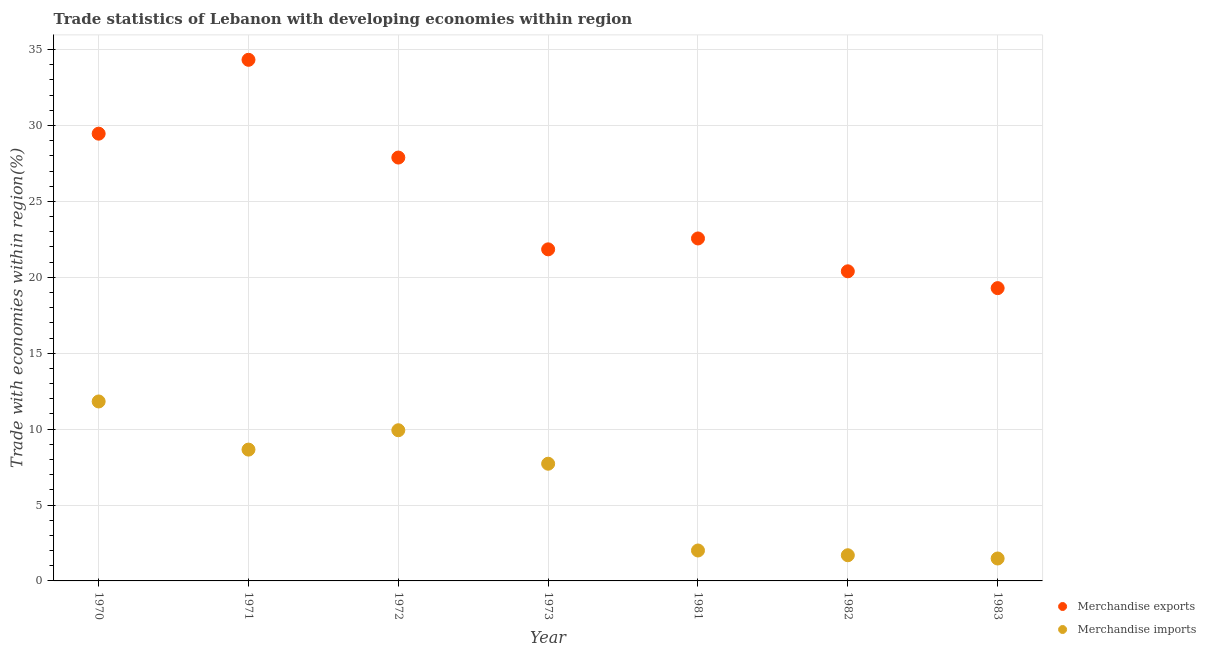How many different coloured dotlines are there?
Your answer should be very brief. 2. What is the merchandise exports in 1970?
Your answer should be compact. 29.46. Across all years, what is the maximum merchandise imports?
Offer a terse response. 11.82. Across all years, what is the minimum merchandise exports?
Ensure brevity in your answer.  19.29. In which year was the merchandise imports maximum?
Keep it short and to the point. 1970. In which year was the merchandise imports minimum?
Offer a terse response. 1983. What is the total merchandise imports in the graph?
Provide a succinct answer. 43.29. What is the difference between the merchandise exports in 1971 and that in 1981?
Your response must be concise. 11.77. What is the difference between the merchandise imports in 1983 and the merchandise exports in 1971?
Ensure brevity in your answer.  -32.85. What is the average merchandise exports per year?
Provide a succinct answer. 25.11. In the year 1973, what is the difference between the merchandise exports and merchandise imports?
Provide a short and direct response. 14.12. In how many years, is the merchandise imports greater than 33 %?
Offer a very short reply. 0. What is the ratio of the merchandise exports in 1972 to that in 1973?
Offer a terse response. 1.28. Is the difference between the merchandise exports in 1971 and 1982 greater than the difference between the merchandise imports in 1971 and 1982?
Ensure brevity in your answer.  Yes. What is the difference between the highest and the second highest merchandise imports?
Provide a succinct answer. 1.9. What is the difference between the highest and the lowest merchandise imports?
Give a very brief answer. 10.34. In how many years, is the merchandise exports greater than the average merchandise exports taken over all years?
Give a very brief answer. 3. Does the graph contain grids?
Your response must be concise. Yes. How are the legend labels stacked?
Offer a very short reply. Vertical. What is the title of the graph?
Your answer should be compact. Trade statistics of Lebanon with developing economies within region. Does "Research and Development" appear as one of the legend labels in the graph?
Your answer should be compact. No. What is the label or title of the Y-axis?
Offer a very short reply. Trade with economies within region(%). What is the Trade with economies within region(%) of Merchandise exports in 1970?
Your response must be concise. 29.46. What is the Trade with economies within region(%) of Merchandise imports in 1970?
Provide a short and direct response. 11.82. What is the Trade with economies within region(%) in Merchandise exports in 1971?
Offer a terse response. 34.33. What is the Trade with economies within region(%) in Merchandise imports in 1971?
Your response must be concise. 8.65. What is the Trade with economies within region(%) of Merchandise exports in 1972?
Give a very brief answer. 27.89. What is the Trade with economies within region(%) in Merchandise imports in 1972?
Provide a short and direct response. 9.93. What is the Trade with economies within region(%) of Merchandise exports in 1973?
Make the answer very short. 21.84. What is the Trade with economies within region(%) of Merchandise imports in 1973?
Ensure brevity in your answer.  7.72. What is the Trade with economies within region(%) of Merchandise exports in 1981?
Your answer should be compact. 22.56. What is the Trade with economies within region(%) in Merchandise imports in 1981?
Offer a terse response. 2. What is the Trade with economies within region(%) of Merchandise exports in 1982?
Your answer should be compact. 20.4. What is the Trade with economies within region(%) of Merchandise imports in 1982?
Offer a terse response. 1.69. What is the Trade with economies within region(%) in Merchandise exports in 1983?
Ensure brevity in your answer.  19.29. What is the Trade with economies within region(%) in Merchandise imports in 1983?
Ensure brevity in your answer.  1.48. Across all years, what is the maximum Trade with economies within region(%) in Merchandise exports?
Provide a succinct answer. 34.33. Across all years, what is the maximum Trade with economies within region(%) of Merchandise imports?
Your answer should be compact. 11.82. Across all years, what is the minimum Trade with economies within region(%) in Merchandise exports?
Offer a terse response. 19.29. Across all years, what is the minimum Trade with economies within region(%) of Merchandise imports?
Your answer should be compact. 1.48. What is the total Trade with economies within region(%) in Merchandise exports in the graph?
Provide a succinct answer. 175.76. What is the total Trade with economies within region(%) of Merchandise imports in the graph?
Your response must be concise. 43.29. What is the difference between the Trade with economies within region(%) of Merchandise exports in 1970 and that in 1971?
Provide a short and direct response. -4.87. What is the difference between the Trade with economies within region(%) of Merchandise imports in 1970 and that in 1971?
Your response must be concise. 3.17. What is the difference between the Trade with economies within region(%) of Merchandise exports in 1970 and that in 1972?
Keep it short and to the point. 1.57. What is the difference between the Trade with economies within region(%) of Merchandise imports in 1970 and that in 1972?
Give a very brief answer. 1.9. What is the difference between the Trade with economies within region(%) of Merchandise exports in 1970 and that in 1973?
Your answer should be compact. 7.62. What is the difference between the Trade with economies within region(%) in Merchandise imports in 1970 and that in 1973?
Your answer should be very brief. 4.1. What is the difference between the Trade with economies within region(%) in Merchandise exports in 1970 and that in 1981?
Ensure brevity in your answer.  6.9. What is the difference between the Trade with economies within region(%) of Merchandise imports in 1970 and that in 1981?
Ensure brevity in your answer.  9.82. What is the difference between the Trade with economies within region(%) of Merchandise exports in 1970 and that in 1982?
Keep it short and to the point. 9.07. What is the difference between the Trade with economies within region(%) of Merchandise imports in 1970 and that in 1982?
Provide a succinct answer. 10.13. What is the difference between the Trade with economies within region(%) in Merchandise exports in 1970 and that in 1983?
Provide a short and direct response. 10.18. What is the difference between the Trade with economies within region(%) of Merchandise imports in 1970 and that in 1983?
Offer a terse response. 10.34. What is the difference between the Trade with economies within region(%) of Merchandise exports in 1971 and that in 1972?
Give a very brief answer. 6.44. What is the difference between the Trade with economies within region(%) of Merchandise imports in 1971 and that in 1972?
Keep it short and to the point. -1.28. What is the difference between the Trade with economies within region(%) in Merchandise exports in 1971 and that in 1973?
Your answer should be compact. 12.49. What is the difference between the Trade with economies within region(%) in Merchandise exports in 1971 and that in 1981?
Your response must be concise. 11.77. What is the difference between the Trade with economies within region(%) in Merchandise imports in 1971 and that in 1981?
Your answer should be very brief. 6.65. What is the difference between the Trade with economies within region(%) of Merchandise exports in 1971 and that in 1982?
Provide a succinct answer. 13.93. What is the difference between the Trade with economies within region(%) of Merchandise imports in 1971 and that in 1982?
Your answer should be compact. 6.96. What is the difference between the Trade with economies within region(%) in Merchandise exports in 1971 and that in 1983?
Your response must be concise. 15.04. What is the difference between the Trade with economies within region(%) in Merchandise imports in 1971 and that in 1983?
Offer a terse response. 7.17. What is the difference between the Trade with economies within region(%) in Merchandise exports in 1972 and that in 1973?
Keep it short and to the point. 6.05. What is the difference between the Trade with economies within region(%) in Merchandise imports in 1972 and that in 1973?
Your answer should be very brief. 2.21. What is the difference between the Trade with economies within region(%) in Merchandise exports in 1972 and that in 1981?
Your answer should be very brief. 5.33. What is the difference between the Trade with economies within region(%) in Merchandise imports in 1972 and that in 1981?
Your answer should be compact. 7.92. What is the difference between the Trade with economies within region(%) of Merchandise exports in 1972 and that in 1982?
Provide a short and direct response. 7.49. What is the difference between the Trade with economies within region(%) in Merchandise imports in 1972 and that in 1982?
Ensure brevity in your answer.  8.23. What is the difference between the Trade with economies within region(%) in Merchandise exports in 1972 and that in 1983?
Your response must be concise. 8.6. What is the difference between the Trade with economies within region(%) of Merchandise imports in 1972 and that in 1983?
Your answer should be compact. 8.45. What is the difference between the Trade with economies within region(%) in Merchandise exports in 1973 and that in 1981?
Offer a terse response. -0.72. What is the difference between the Trade with economies within region(%) of Merchandise imports in 1973 and that in 1981?
Keep it short and to the point. 5.72. What is the difference between the Trade with economies within region(%) in Merchandise exports in 1973 and that in 1982?
Provide a succinct answer. 1.45. What is the difference between the Trade with economies within region(%) in Merchandise imports in 1973 and that in 1982?
Give a very brief answer. 6.03. What is the difference between the Trade with economies within region(%) of Merchandise exports in 1973 and that in 1983?
Your answer should be compact. 2.56. What is the difference between the Trade with economies within region(%) of Merchandise imports in 1973 and that in 1983?
Keep it short and to the point. 6.24. What is the difference between the Trade with economies within region(%) of Merchandise exports in 1981 and that in 1982?
Your answer should be very brief. 2.16. What is the difference between the Trade with economies within region(%) of Merchandise imports in 1981 and that in 1982?
Keep it short and to the point. 0.31. What is the difference between the Trade with economies within region(%) of Merchandise exports in 1981 and that in 1983?
Keep it short and to the point. 3.27. What is the difference between the Trade with economies within region(%) in Merchandise imports in 1981 and that in 1983?
Ensure brevity in your answer.  0.53. What is the difference between the Trade with economies within region(%) in Merchandise exports in 1982 and that in 1983?
Provide a short and direct response. 1.11. What is the difference between the Trade with economies within region(%) of Merchandise imports in 1982 and that in 1983?
Ensure brevity in your answer.  0.21. What is the difference between the Trade with economies within region(%) in Merchandise exports in 1970 and the Trade with economies within region(%) in Merchandise imports in 1971?
Provide a succinct answer. 20.81. What is the difference between the Trade with economies within region(%) of Merchandise exports in 1970 and the Trade with economies within region(%) of Merchandise imports in 1972?
Provide a succinct answer. 19.54. What is the difference between the Trade with economies within region(%) in Merchandise exports in 1970 and the Trade with economies within region(%) in Merchandise imports in 1973?
Provide a succinct answer. 21.74. What is the difference between the Trade with economies within region(%) of Merchandise exports in 1970 and the Trade with economies within region(%) of Merchandise imports in 1981?
Make the answer very short. 27.46. What is the difference between the Trade with economies within region(%) of Merchandise exports in 1970 and the Trade with economies within region(%) of Merchandise imports in 1982?
Offer a very short reply. 27.77. What is the difference between the Trade with economies within region(%) of Merchandise exports in 1970 and the Trade with economies within region(%) of Merchandise imports in 1983?
Keep it short and to the point. 27.99. What is the difference between the Trade with economies within region(%) of Merchandise exports in 1971 and the Trade with economies within region(%) of Merchandise imports in 1972?
Provide a short and direct response. 24.4. What is the difference between the Trade with economies within region(%) in Merchandise exports in 1971 and the Trade with economies within region(%) in Merchandise imports in 1973?
Provide a short and direct response. 26.61. What is the difference between the Trade with economies within region(%) of Merchandise exports in 1971 and the Trade with economies within region(%) of Merchandise imports in 1981?
Offer a very short reply. 32.32. What is the difference between the Trade with economies within region(%) in Merchandise exports in 1971 and the Trade with economies within region(%) in Merchandise imports in 1982?
Your answer should be compact. 32.64. What is the difference between the Trade with economies within region(%) of Merchandise exports in 1971 and the Trade with economies within region(%) of Merchandise imports in 1983?
Make the answer very short. 32.85. What is the difference between the Trade with economies within region(%) of Merchandise exports in 1972 and the Trade with economies within region(%) of Merchandise imports in 1973?
Give a very brief answer. 20.17. What is the difference between the Trade with economies within region(%) in Merchandise exports in 1972 and the Trade with economies within region(%) in Merchandise imports in 1981?
Provide a succinct answer. 25.89. What is the difference between the Trade with economies within region(%) in Merchandise exports in 1972 and the Trade with economies within region(%) in Merchandise imports in 1982?
Make the answer very short. 26.2. What is the difference between the Trade with economies within region(%) in Merchandise exports in 1972 and the Trade with economies within region(%) in Merchandise imports in 1983?
Give a very brief answer. 26.41. What is the difference between the Trade with economies within region(%) of Merchandise exports in 1973 and the Trade with economies within region(%) of Merchandise imports in 1981?
Ensure brevity in your answer.  19.84. What is the difference between the Trade with economies within region(%) in Merchandise exports in 1973 and the Trade with economies within region(%) in Merchandise imports in 1982?
Offer a terse response. 20.15. What is the difference between the Trade with economies within region(%) in Merchandise exports in 1973 and the Trade with economies within region(%) in Merchandise imports in 1983?
Provide a succinct answer. 20.37. What is the difference between the Trade with economies within region(%) of Merchandise exports in 1981 and the Trade with economies within region(%) of Merchandise imports in 1982?
Keep it short and to the point. 20.87. What is the difference between the Trade with economies within region(%) in Merchandise exports in 1981 and the Trade with economies within region(%) in Merchandise imports in 1983?
Provide a short and direct response. 21.08. What is the difference between the Trade with economies within region(%) in Merchandise exports in 1982 and the Trade with economies within region(%) in Merchandise imports in 1983?
Ensure brevity in your answer.  18.92. What is the average Trade with economies within region(%) in Merchandise exports per year?
Provide a short and direct response. 25.11. What is the average Trade with economies within region(%) in Merchandise imports per year?
Make the answer very short. 6.18. In the year 1970, what is the difference between the Trade with economies within region(%) in Merchandise exports and Trade with economies within region(%) in Merchandise imports?
Give a very brief answer. 17.64. In the year 1971, what is the difference between the Trade with economies within region(%) in Merchandise exports and Trade with economies within region(%) in Merchandise imports?
Keep it short and to the point. 25.68. In the year 1972, what is the difference between the Trade with economies within region(%) of Merchandise exports and Trade with economies within region(%) of Merchandise imports?
Provide a short and direct response. 17.96. In the year 1973, what is the difference between the Trade with economies within region(%) of Merchandise exports and Trade with economies within region(%) of Merchandise imports?
Your answer should be compact. 14.12. In the year 1981, what is the difference between the Trade with economies within region(%) of Merchandise exports and Trade with economies within region(%) of Merchandise imports?
Your answer should be compact. 20.56. In the year 1982, what is the difference between the Trade with economies within region(%) of Merchandise exports and Trade with economies within region(%) of Merchandise imports?
Provide a succinct answer. 18.7. In the year 1983, what is the difference between the Trade with economies within region(%) in Merchandise exports and Trade with economies within region(%) in Merchandise imports?
Your response must be concise. 17.81. What is the ratio of the Trade with economies within region(%) in Merchandise exports in 1970 to that in 1971?
Offer a terse response. 0.86. What is the ratio of the Trade with economies within region(%) in Merchandise imports in 1970 to that in 1971?
Your answer should be very brief. 1.37. What is the ratio of the Trade with economies within region(%) in Merchandise exports in 1970 to that in 1972?
Your answer should be very brief. 1.06. What is the ratio of the Trade with economies within region(%) in Merchandise imports in 1970 to that in 1972?
Your response must be concise. 1.19. What is the ratio of the Trade with economies within region(%) of Merchandise exports in 1970 to that in 1973?
Provide a succinct answer. 1.35. What is the ratio of the Trade with economies within region(%) in Merchandise imports in 1970 to that in 1973?
Keep it short and to the point. 1.53. What is the ratio of the Trade with economies within region(%) of Merchandise exports in 1970 to that in 1981?
Ensure brevity in your answer.  1.31. What is the ratio of the Trade with economies within region(%) of Merchandise imports in 1970 to that in 1981?
Give a very brief answer. 5.9. What is the ratio of the Trade with economies within region(%) in Merchandise exports in 1970 to that in 1982?
Make the answer very short. 1.44. What is the ratio of the Trade with economies within region(%) of Merchandise imports in 1970 to that in 1982?
Provide a succinct answer. 6.99. What is the ratio of the Trade with economies within region(%) of Merchandise exports in 1970 to that in 1983?
Offer a very short reply. 1.53. What is the ratio of the Trade with economies within region(%) of Merchandise imports in 1970 to that in 1983?
Your answer should be compact. 8. What is the ratio of the Trade with economies within region(%) of Merchandise exports in 1971 to that in 1972?
Offer a very short reply. 1.23. What is the ratio of the Trade with economies within region(%) of Merchandise imports in 1971 to that in 1972?
Provide a short and direct response. 0.87. What is the ratio of the Trade with economies within region(%) in Merchandise exports in 1971 to that in 1973?
Ensure brevity in your answer.  1.57. What is the ratio of the Trade with economies within region(%) in Merchandise imports in 1971 to that in 1973?
Give a very brief answer. 1.12. What is the ratio of the Trade with economies within region(%) of Merchandise exports in 1971 to that in 1981?
Keep it short and to the point. 1.52. What is the ratio of the Trade with economies within region(%) of Merchandise imports in 1971 to that in 1981?
Offer a terse response. 4.32. What is the ratio of the Trade with economies within region(%) of Merchandise exports in 1971 to that in 1982?
Your response must be concise. 1.68. What is the ratio of the Trade with economies within region(%) in Merchandise imports in 1971 to that in 1982?
Offer a terse response. 5.11. What is the ratio of the Trade with economies within region(%) in Merchandise exports in 1971 to that in 1983?
Your answer should be compact. 1.78. What is the ratio of the Trade with economies within region(%) in Merchandise imports in 1971 to that in 1983?
Provide a succinct answer. 5.86. What is the ratio of the Trade with economies within region(%) in Merchandise exports in 1972 to that in 1973?
Your answer should be very brief. 1.28. What is the ratio of the Trade with economies within region(%) in Merchandise imports in 1972 to that in 1973?
Make the answer very short. 1.29. What is the ratio of the Trade with economies within region(%) of Merchandise exports in 1972 to that in 1981?
Your answer should be compact. 1.24. What is the ratio of the Trade with economies within region(%) of Merchandise imports in 1972 to that in 1981?
Give a very brief answer. 4.95. What is the ratio of the Trade with economies within region(%) in Merchandise exports in 1972 to that in 1982?
Provide a succinct answer. 1.37. What is the ratio of the Trade with economies within region(%) of Merchandise imports in 1972 to that in 1982?
Provide a succinct answer. 5.87. What is the ratio of the Trade with economies within region(%) of Merchandise exports in 1972 to that in 1983?
Provide a succinct answer. 1.45. What is the ratio of the Trade with economies within region(%) in Merchandise imports in 1972 to that in 1983?
Your answer should be very brief. 6.72. What is the ratio of the Trade with economies within region(%) of Merchandise exports in 1973 to that in 1981?
Make the answer very short. 0.97. What is the ratio of the Trade with economies within region(%) in Merchandise imports in 1973 to that in 1981?
Keep it short and to the point. 3.85. What is the ratio of the Trade with economies within region(%) in Merchandise exports in 1973 to that in 1982?
Give a very brief answer. 1.07. What is the ratio of the Trade with economies within region(%) of Merchandise imports in 1973 to that in 1982?
Your answer should be very brief. 4.56. What is the ratio of the Trade with economies within region(%) in Merchandise exports in 1973 to that in 1983?
Offer a terse response. 1.13. What is the ratio of the Trade with economies within region(%) in Merchandise imports in 1973 to that in 1983?
Keep it short and to the point. 5.23. What is the ratio of the Trade with economies within region(%) in Merchandise exports in 1981 to that in 1982?
Keep it short and to the point. 1.11. What is the ratio of the Trade with economies within region(%) in Merchandise imports in 1981 to that in 1982?
Provide a short and direct response. 1.18. What is the ratio of the Trade with economies within region(%) of Merchandise exports in 1981 to that in 1983?
Provide a succinct answer. 1.17. What is the ratio of the Trade with economies within region(%) of Merchandise imports in 1981 to that in 1983?
Your response must be concise. 1.36. What is the ratio of the Trade with economies within region(%) of Merchandise exports in 1982 to that in 1983?
Offer a terse response. 1.06. What is the ratio of the Trade with economies within region(%) in Merchandise imports in 1982 to that in 1983?
Offer a terse response. 1.15. What is the difference between the highest and the second highest Trade with economies within region(%) in Merchandise exports?
Give a very brief answer. 4.87. What is the difference between the highest and the second highest Trade with economies within region(%) of Merchandise imports?
Your response must be concise. 1.9. What is the difference between the highest and the lowest Trade with economies within region(%) of Merchandise exports?
Keep it short and to the point. 15.04. What is the difference between the highest and the lowest Trade with economies within region(%) of Merchandise imports?
Your answer should be compact. 10.34. 